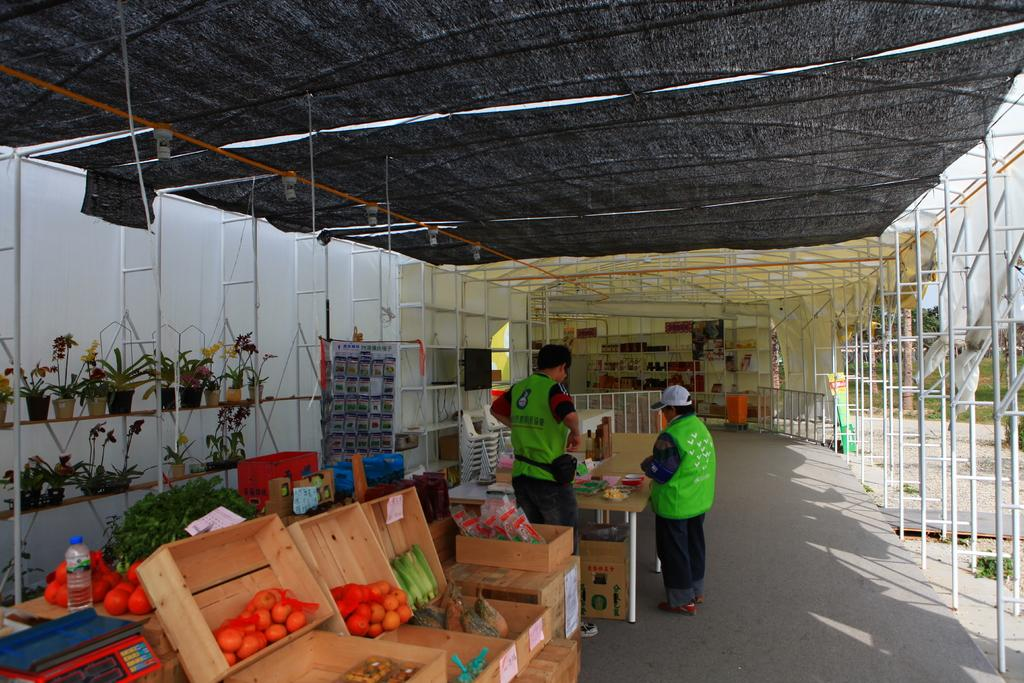How many people are present in the image? There are two persons standing in the image. What is the surface on which the persons are standing? The persons are standing on the floor. What type of food items can be seen in the image? There are vegetables in the image. What can be seen in the background of the image? There are plants and a shed in the background of the image. What type of amusement can be seen in the image? There is no amusement present in the image; it features two persons standing on the floor with vegetables and a background of plants and a shed. Is there a cannon visible in the image? No, there is no cannon present in the image. 